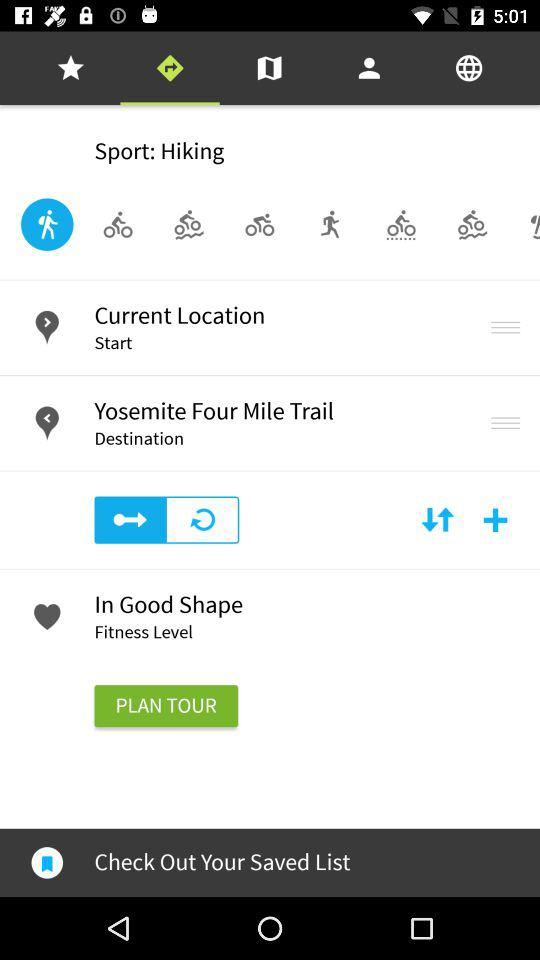What is the starting point? The starting point is your current location. 